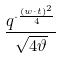Convert formula to latex. <formula><loc_0><loc_0><loc_500><loc_500>\frac { q ^ { \cdot \frac { ( w \cdot t ) ^ { 2 } } { 4 } } } { \sqrt { 4 \vartheta } }</formula> 